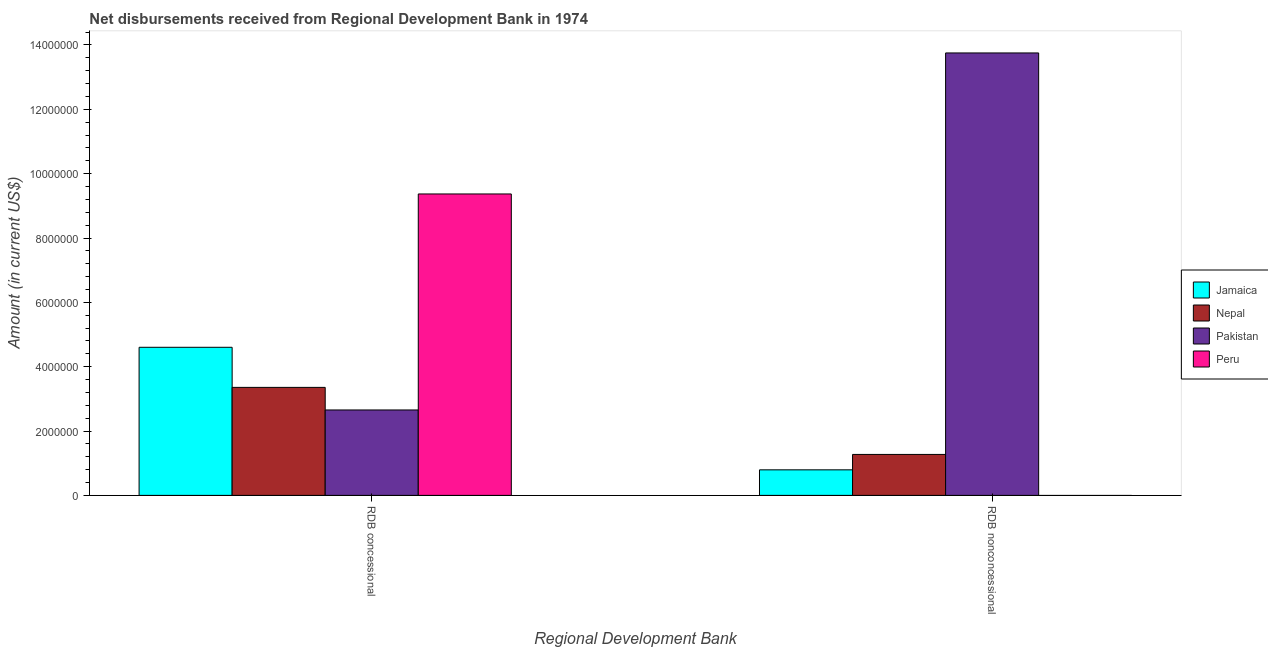How many bars are there on the 1st tick from the left?
Your answer should be compact. 4. What is the label of the 2nd group of bars from the left?
Ensure brevity in your answer.  RDB nonconcessional. Across all countries, what is the maximum net concessional disbursements from rdb?
Offer a very short reply. 9.37e+06. What is the total net non concessional disbursements from rdb in the graph?
Provide a succinct answer. 1.58e+07. What is the difference between the net concessional disbursements from rdb in Nepal and that in Jamaica?
Your answer should be compact. -1.25e+06. What is the difference between the net concessional disbursements from rdb in Peru and the net non concessional disbursements from rdb in Pakistan?
Ensure brevity in your answer.  -4.38e+06. What is the average net non concessional disbursements from rdb per country?
Your response must be concise. 3.95e+06. What is the difference between the net concessional disbursements from rdb and net non concessional disbursements from rdb in Nepal?
Offer a very short reply. 2.08e+06. In how many countries, is the net non concessional disbursements from rdb greater than 2800000 US$?
Your answer should be compact. 1. What is the ratio of the net concessional disbursements from rdb in Nepal to that in Peru?
Offer a terse response. 0.36. Is the net concessional disbursements from rdb in Peru less than that in Nepal?
Your answer should be compact. No. How many bars are there?
Your answer should be very brief. 7. What is the difference between two consecutive major ticks on the Y-axis?
Ensure brevity in your answer.  2.00e+06. Are the values on the major ticks of Y-axis written in scientific E-notation?
Offer a very short reply. No. Where does the legend appear in the graph?
Ensure brevity in your answer.  Center right. How many legend labels are there?
Provide a short and direct response. 4. How are the legend labels stacked?
Your answer should be compact. Vertical. What is the title of the graph?
Provide a short and direct response. Net disbursements received from Regional Development Bank in 1974. What is the label or title of the X-axis?
Offer a terse response. Regional Development Bank. What is the label or title of the Y-axis?
Offer a very short reply. Amount (in current US$). What is the Amount (in current US$) in Jamaica in RDB concessional?
Make the answer very short. 4.60e+06. What is the Amount (in current US$) of Nepal in RDB concessional?
Ensure brevity in your answer.  3.36e+06. What is the Amount (in current US$) of Pakistan in RDB concessional?
Keep it short and to the point. 2.66e+06. What is the Amount (in current US$) of Peru in RDB concessional?
Your answer should be compact. 9.37e+06. What is the Amount (in current US$) in Jamaica in RDB nonconcessional?
Make the answer very short. 7.94e+05. What is the Amount (in current US$) in Nepal in RDB nonconcessional?
Provide a short and direct response. 1.27e+06. What is the Amount (in current US$) of Pakistan in RDB nonconcessional?
Your response must be concise. 1.38e+07. Across all Regional Development Bank, what is the maximum Amount (in current US$) in Jamaica?
Offer a very short reply. 4.60e+06. Across all Regional Development Bank, what is the maximum Amount (in current US$) of Nepal?
Provide a succinct answer. 3.36e+06. Across all Regional Development Bank, what is the maximum Amount (in current US$) in Pakistan?
Offer a very short reply. 1.38e+07. Across all Regional Development Bank, what is the maximum Amount (in current US$) in Peru?
Your response must be concise. 9.37e+06. Across all Regional Development Bank, what is the minimum Amount (in current US$) of Jamaica?
Make the answer very short. 7.94e+05. Across all Regional Development Bank, what is the minimum Amount (in current US$) of Nepal?
Offer a terse response. 1.27e+06. Across all Regional Development Bank, what is the minimum Amount (in current US$) of Pakistan?
Make the answer very short. 2.66e+06. Across all Regional Development Bank, what is the minimum Amount (in current US$) in Peru?
Your response must be concise. 0. What is the total Amount (in current US$) of Jamaica in the graph?
Your answer should be very brief. 5.40e+06. What is the total Amount (in current US$) in Nepal in the graph?
Your answer should be very brief. 4.63e+06. What is the total Amount (in current US$) in Pakistan in the graph?
Your answer should be very brief. 1.64e+07. What is the total Amount (in current US$) in Peru in the graph?
Provide a short and direct response. 9.37e+06. What is the difference between the Amount (in current US$) in Jamaica in RDB concessional and that in RDB nonconcessional?
Make the answer very short. 3.81e+06. What is the difference between the Amount (in current US$) in Nepal in RDB concessional and that in RDB nonconcessional?
Offer a terse response. 2.08e+06. What is the difference between the Amount (in current US$) of Pakistan in RDB concessional and that in RDB nonconcessional?
Ensure brevity in your answer.  -1.11e+07. What is the difference between the Amount (in current US$) in Jamaica in RDB concessional and the Amount (in current US$) in Nepal in RDB nonconcessional?
Offer a very short reply. 3.33e+06. What is the difference between the Amount (in current US$) of Jamaica in RDB concessional and the Amount (in current US$) of Pakistan in RDB nonconcessional?
Offer a terse response. -9.15e+06. What is the difference between the Amount (in current US$) of Nepal in RDB concessional and the Amount (in current US$) of Pakistan in RDB nonconcessional?
Keep it short and to the point. -1.04e+07. What is the average Amount (in current US$) in Jamaica per Regional Development Bank?
Provide a succinct answer. 2.70e+06. What is the average Amount (in current US$) in Nepal per Regional Development Bank?
Provide a succinct answer. 2.32e+06. What is the average Amount (in current US$) of Pakistan per Regional Development Bank?
Keep it short and to the point. 8.20e+06. What is the average Amount (in current US$) of Peru per Regional Development Bank?
Offer a very short reply. 4.68e+06. What is the difference between the Amount (in current US$) in Jamaica and Amount (in current US$) in Nepal in RDB concessional?
Give a very brief answer. 1.25e+06. What is the difference between the Amount (in current US$) in Jamaica and Amount (in current US$) in Pakistan in RDB concessional?
Keep it short and to the point. 1.95e+06. What is the difference between the Amount (in current US$) in Jamaica and Amount (in current US$) in Peru in RDB concessional?
Keep it short and to the point. -4.77e+06. What is the difference between the Amount (in current US$) in Nepal and Amount (in current US$) in Pakistan in RDB concessional?
Your answer should be very brief. 7.02e+05. What is the difference between the Amount (in current US$) of Nepal and Amount (in current US$) of Peru in RDB concessional?
Provide a succinct answer. -6.01e+06. What is the difference between the Amount (in current US$) in Pakistan and Amount (in current US$) in Peru in RDB concessional?
Offer a terse response. -6.71e+06. What is the difference between the Amount (in current US$) in Jamaica and Amount (in current US$) in Nepal in RDB nonconcessional?
Your answer should be compact. -4.79e+05. What is the difference between the Amount (in current US$) in Jamaica and Amount (in current US$) in Pakistan in RDB nonconcessional?
Give a very brief answer. -1.30e+07. What is the difference between the Amount (in current US$) of Nepal and Amount (in current US$) of Pakistan in RDB nonconcessional?
Your response must be concise. -1.25e+07. What is the ratio of the Amount (in current US$) in Jamaica in RDB concessional to that in RDB nonconcessional?
Your response must be concise. 5.8. What is the ratio of the Amount (in current US$) of Nepal in RDB concessional to that in RDB nonconcessional?
Provide a succinct answer. 2.64. What is the ratio of the Amount (in current US$) in Pakistan in RDB concessional to that in RDB nonconcessional?
Make the answer very short. 0.19. What is the difference between the highest and the second highest Amount (in current US$) of Jamaica?
Your answer should be compact. 3.81e+06. What is the difference between the highest and the second highest Amount (in current US$) in Nepal?
Provide a short and direct response. 2.08e+06. What is the difference between the highest and the second highest Amount (in current US$) in Pakistan?
Give a very brief answer. 1.11e+07. What is the difference between the highest and the lowest Amount (in current US$) in Jamaica?
Your answer should be compact. 3.81e+06. What is the difference between the highest and the lowest Amount (in current US$) of Nepal?
Provide a succinct answer. 2.08e+06. What is the difference between the highest and the lowest Amount (in current US$) of Pakistan?
Make the answer very short. 1.11e+07. What is the difference between the highest and the lowest Amount (in current US$) in Peru?
Give a very brief answer. 9.37e+06. 